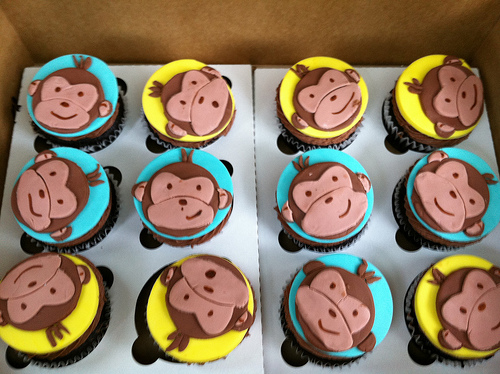<image>
Can you confirm if the monkey is on the cake? Yes. Looking at the image, I can see the monkey is positioned on top of the cake, with the cake providing support. Is there a blue cupcake on the yellow cupcake? No. The blue cupcake is not positioned on the yellow cupcake. They may be near each other, but the blue cupcake is not supported by or resting on top of the yellow cupcake. 